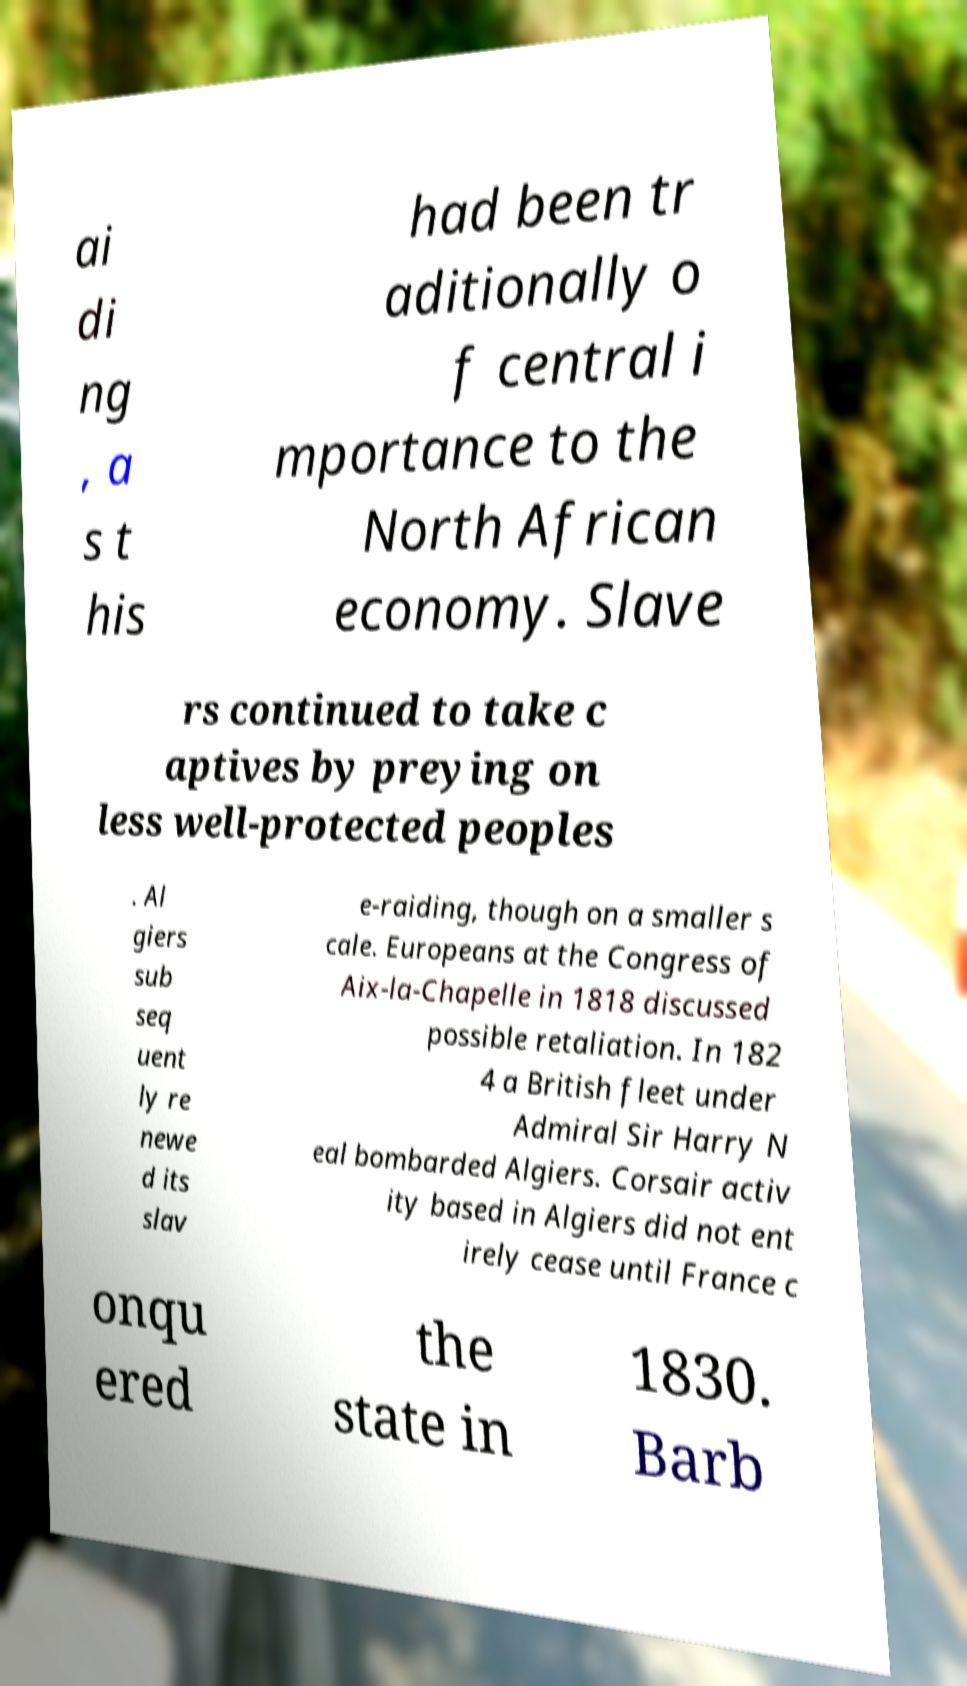What messages or text are displayed in this image? I need them in a readable, typed format. ai di ng , a s t his had been tr aditionally o f central i mportance to the North African economy. Slave rs continued to take c aptives by preying on less well-protected peoples . Al giers sub seq uent ly re newe d its slav e-raiding, though on a smaller s cale. Europeans at the Congress of Aix-la-Chapelle in 1818 discussed possible retaliation. In 182 4 a British fleet under Admiral Sir Harry N eal bombarded Algiers. Corsair activ ity based in Algiers did not ent irely cease until France c onqu ered the state in 1830. Barb 